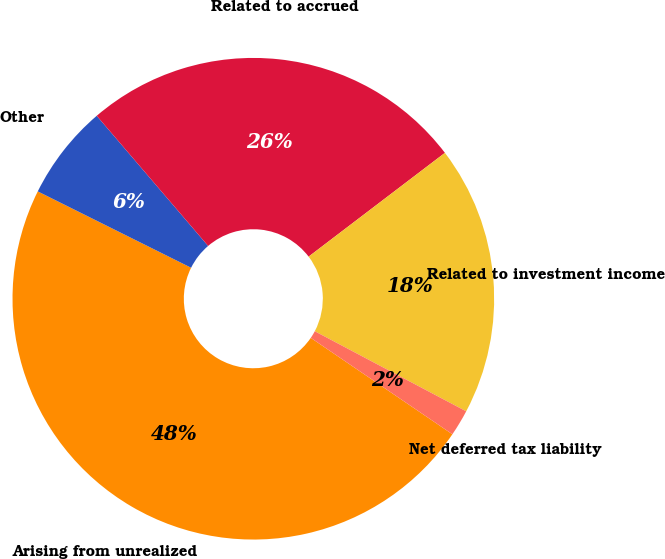Convert chart to OTSL. <chart><loc_0><loc_0><loc_500><loc_500><pie_chart><fcel>Arising from unrealized<fcel>Other<fcel>Related to accrued<fcel>Related to investment income<fcel>Net deferred tax liability<nl><fcel>47.84%<fcel>6.38%<fcel>25.91%<fcel>18.1%<fcel>1.77%<nl></chart> 